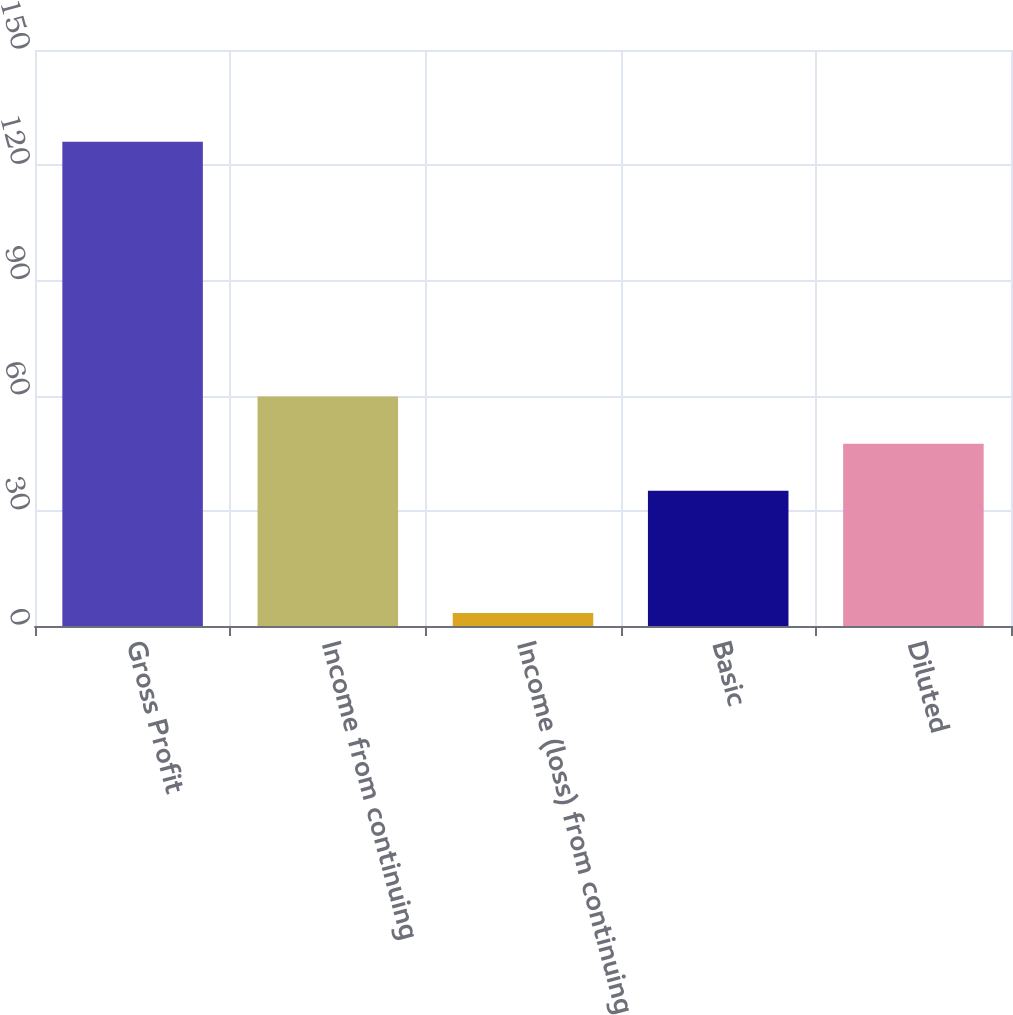Convert chart to OTSL. <chart><loc_0><loc_0><loc_500><loc_500><bar_chart><fcel>Gross Profit<fcel>Income from continuing<fcel>Income (loss) from continuing<fcel>Basic<fcel>Diluted<nl><fcel>126.1<fcel>59.74<fcel>3.4<fcel>35.2<fcel>47.47<nl></chart> 